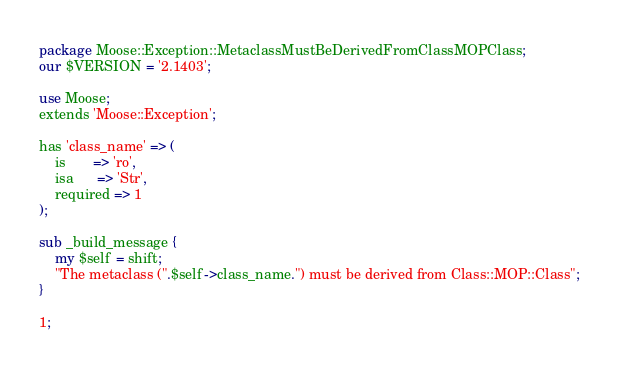Convert code to text. <code><loc_0><loc_0><loc_500><loc_500><_Perl_>package Moose::Exception::MetaclassMustBeDerivedFromClassMOPClass;
our $VERSION = '2.1403';

use Moose;
extends 'Moose::Exception';

has 'class_name' => (
    is       => 'ro',
    isa      => 'Str',
    required => 1
);

sub _build_message {
    my $self = shift;
    "The metaclass (".$self->class_name.") must be derived from Class::MOP::Class";
}

1;
</code> 